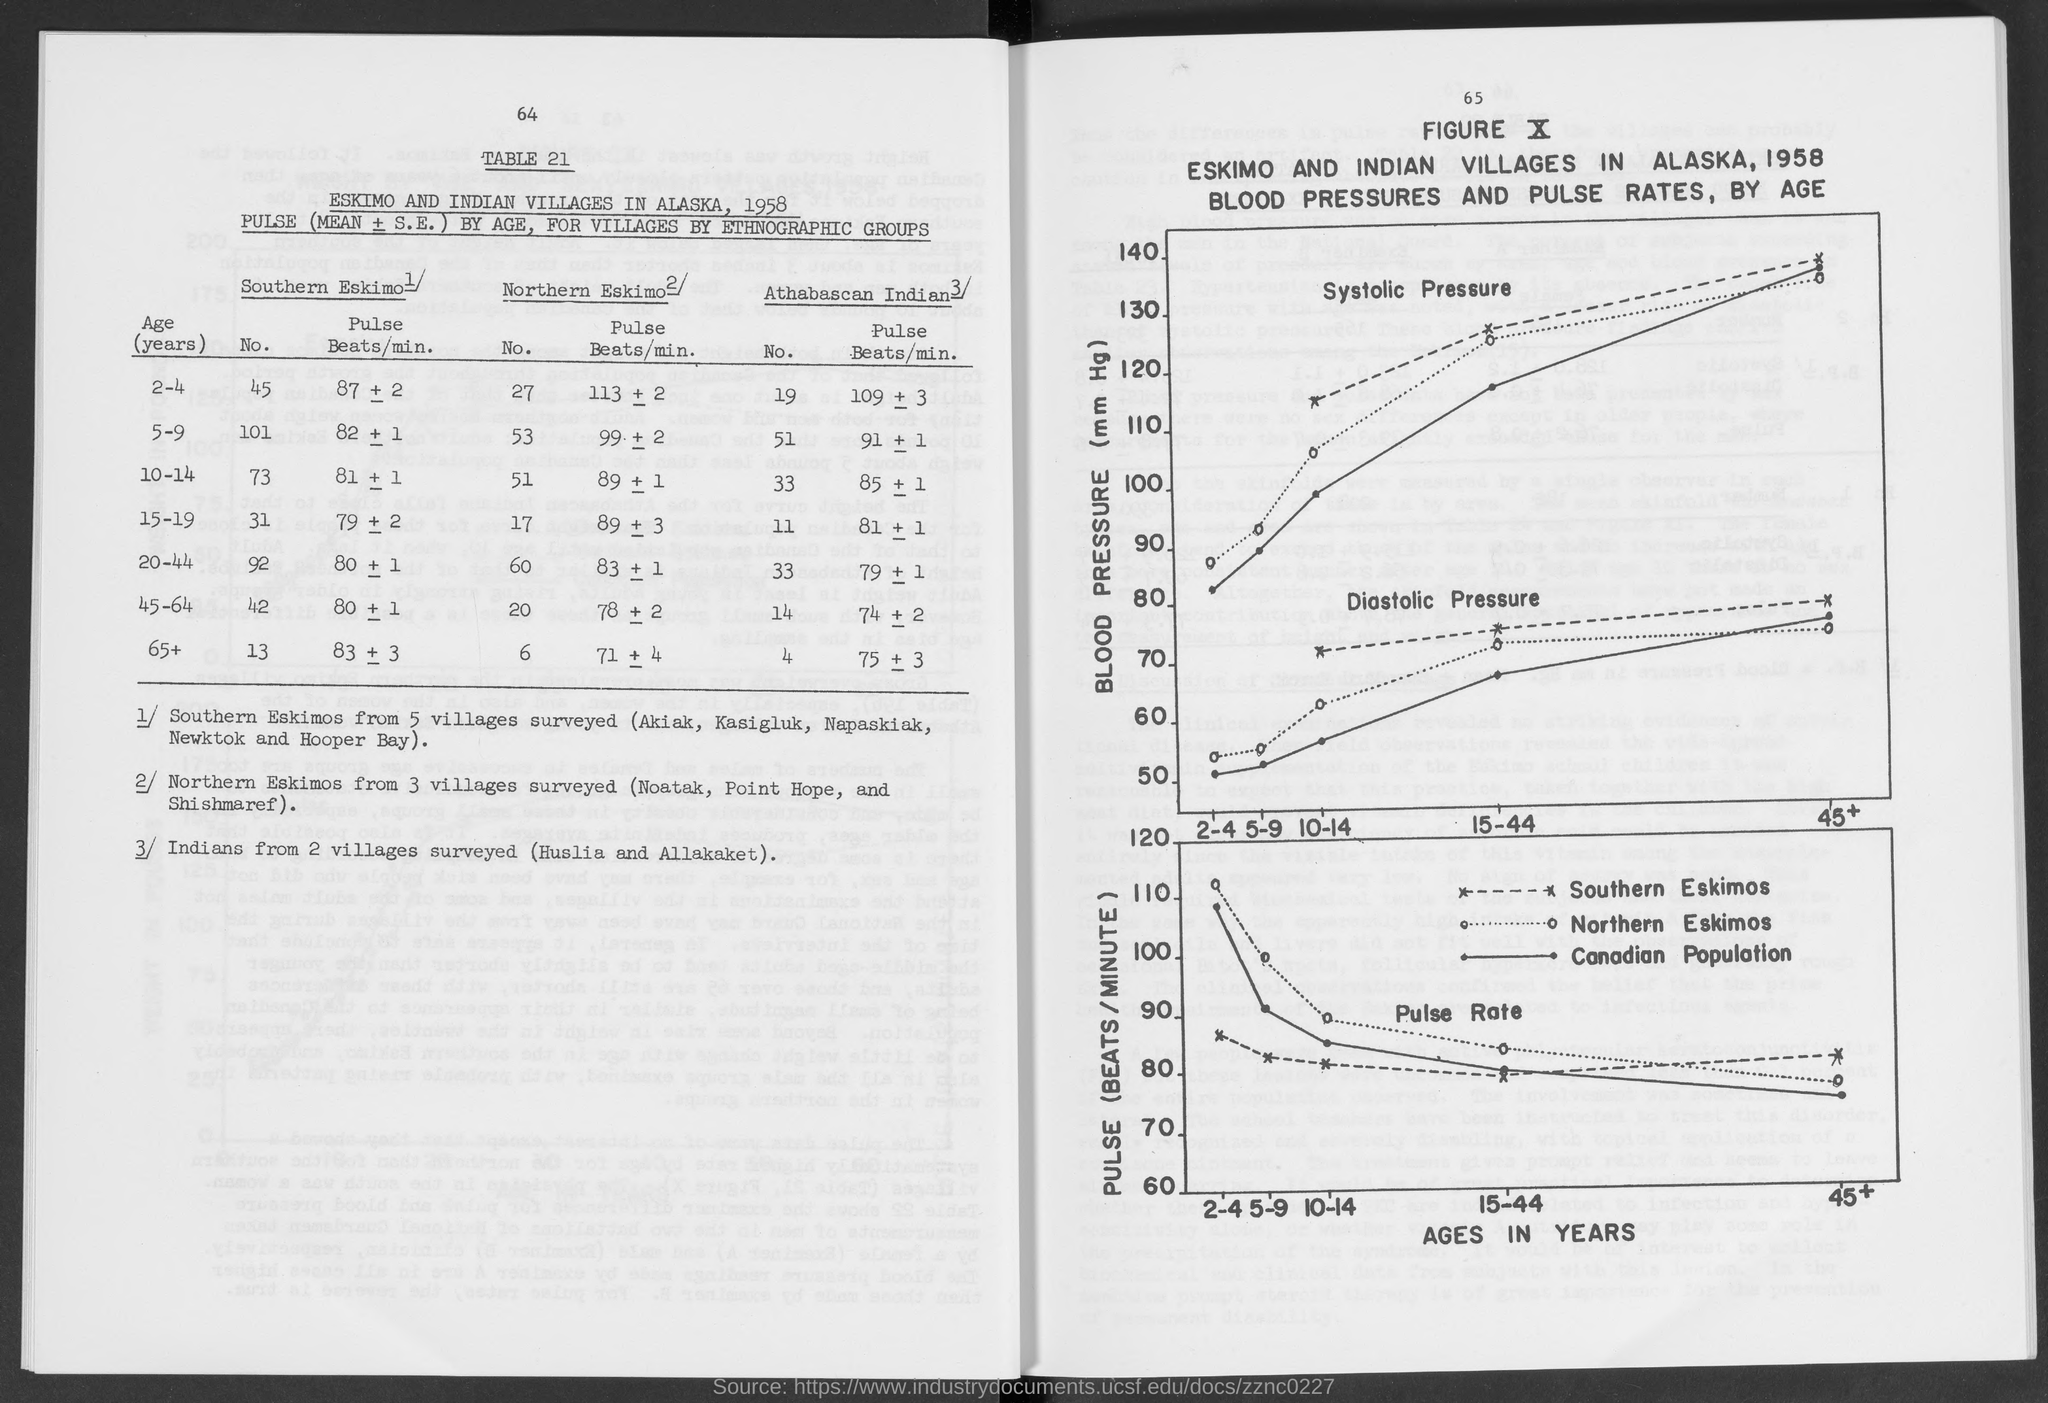Outline some significant characteristics in this image. The Canadian population is represented by a bold line. 